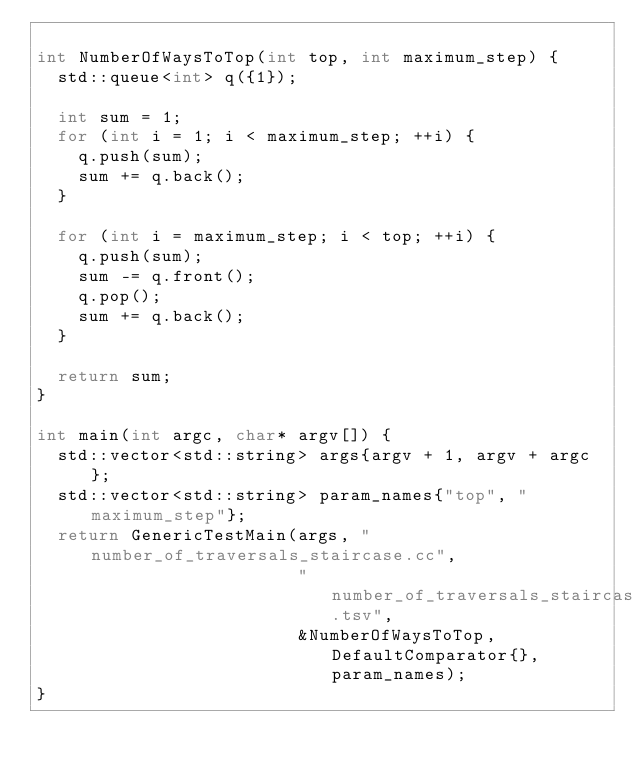Convert code to text. <code><loc_0><loc_0><loc_500><loc_500><_C++_>
int NumberOfWaysToTop(int top, int maximum_step) {
  std::queue<int> q({1});

  int sum = 1;
  for (int i = 1; i < maximum_step; ++i) {
    q.push(sum);
    sum += q.back();
  }

  for (int i = maximum_step; i < top; ++i) {
    q.push(sum);
    sum -= q.front();
    q.pop();
    sum += q.back();
  }

  return sum;
}

int main(int argc, char* argv[]) {
  std::vector<std::string> args{argv + 1, argv + argc};
  std::vector<std::string> param_names{"top", "maximum_step"};
  return GenericTestMain(args, "number_of_traversals_staircase.cc",
                         "number_of_traversals_staircase.tsv",
                         &NumberOfWaysToTop, DefaultComparator{}, param_names);
}
</code> 